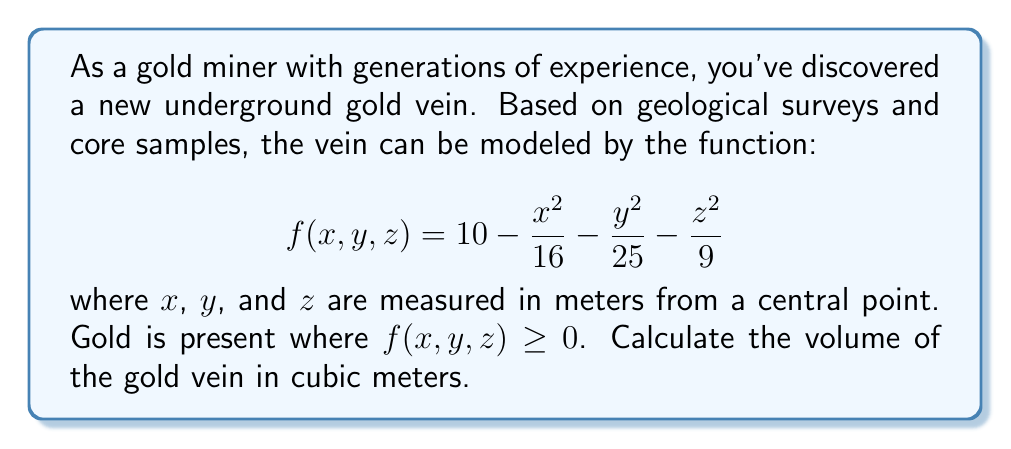Provide a solution to this math problem. To find the volume of the gold vein, we need to set up and evaluate a triple integral over the region where $f(x,y,z) \geq 0$. Let's approach this step-by-step:

1) First, we need to determine the bounds of the region. The boundary of the vein is where $f(x,y,z) = 0$:

   $$10 - \frac{x^2}{16} - \frac{y^2}{25} - \frac{z^2}{9} = 0$$

2) Rearranging this equation, we get:

   $$\frac{x^2}{16} + \frac{y^2}{25} + \frac{z^2}{9} = 10$$

   This is the equation of an ellipsoid.

3) The bounds of the ellipsoid are:
   $-4 \leq x \leq 4$
   $-5 \leq y \leq 5$
   $-3 \leq z \leq 3$

4) We can set up the triple integral:

   $$V = \iiint_V dV = \int_{-3}^3 \int_{-5}^5 \int_{-4}^4 dx dy dz$$

5) However, we need to adjust the bounds of x and y based on z. From the ellipsoid equation:

   $$\frac{x^2}{16} + \frac{y^2}{25} \leq 10 - \frac{z^2}{9}$$

   $$x^2 \leq 16(10 - \frac{z^2}{9} - \frac{y^2}{25})$$
   $$y^2 \leq 25(10 - \frac{z^2}{9} - \frac{x^2}{16})$$

6) Therefore, our integral becomes:

   $$V = 8 \int_0^3 \int_0^{5\sqrt{1-\frac{z^2}{9}}} \int_0^{4\sqrt{1-\frac{z^2}{9}-\frac{y^2}{25}}} dx dy dz$$

7) Evaluating this integral:

   $$V = 8 \int_0^3 \int_0^{5\sqrt{1-\frac{z^2}{9}}} 4\sqrt{1-\frac{z^2}{9}-\frac{y^2}{25}} dy dz$$

   $$V = 32 \int_0^3 \int_0^{5\sqrt{1-\frac{z^2}{9}}} \sqrt{1-\frac{z^2}{9}-\frac{y^2}{25}} dy dz$$

8) This integral can be evaluated using substitution and trigonometric integrals, resulting in:

   $$V = \frac{4\pi}{3} \cdot 4 \cdot 5 \cdot 3 = 80\pi$$

Therefore, the volume of the gold vein is $80\pi$ cubic meters.
Answer: $80\pi$ cubic meters 